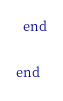Convert code to text. <code><loc_0><loc_0><loc_500><loc_500><_Ruby_>  end

end</code> 